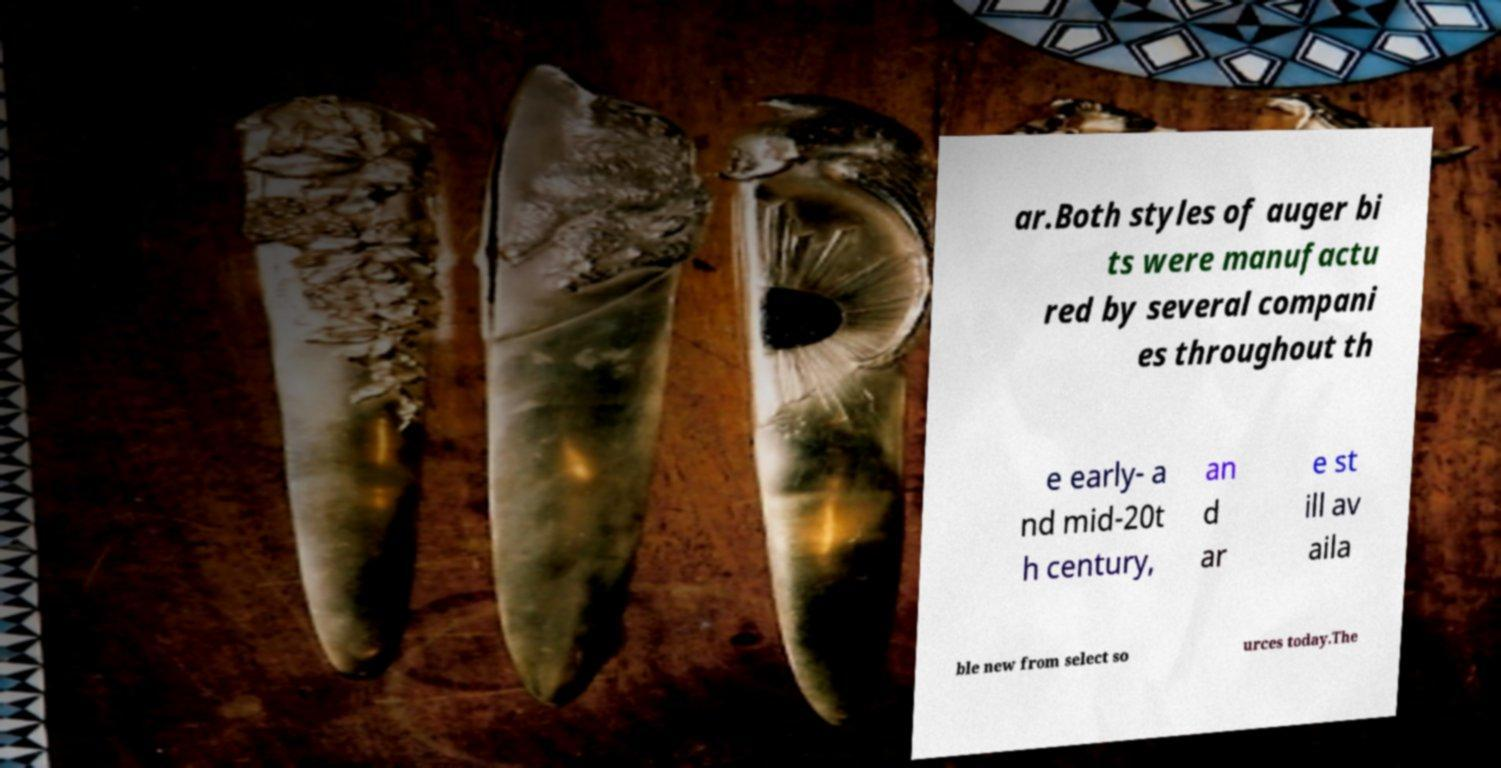For documentation purposes, I need the text within this image transcribed. Could you provide that? ar.Both styles of auger bi ts were manufactu red by several compani es throughout th e early- a nd mid-20t h century, an d ar e st ill av aila ble new from select so urces today.The 